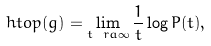Convert formula to latex. <formula><loc_0><loc_0><loc_500><loc_500>\ h t o p ( g ) = \lim _ { t \ r a \infty } \frac { 1 } { t } \log P ( t ) ,</formula> 